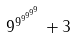Convert formula to latex. <formula><loc_0><loc_0><loc_500><loc_500>9 ^ { 9 ^ { 9 ^ { 9 ^ { 9 ^ { 9 } } } } } + 3</formula> 